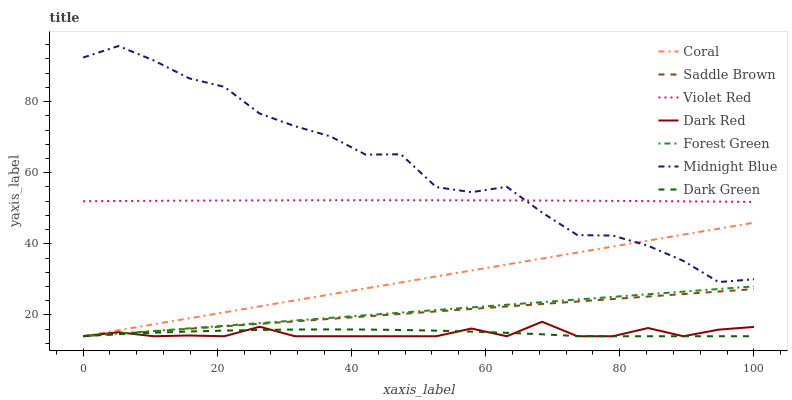Does Dark Red have the minimum area under the curve?
Answer yes or no. Yes. Does Midnight Blue have the maximum area under the curve?
Answer yes or no. Yes. Does Midnight Blue have the minimum area under the curve?
Answer yes or no. No. Does Dark Red have the maximum area under the curve?
Answer yes or no. No. Is Saddle Brown the smoothest?
Answer yes or no. Yes. Is Midnight Blue the roughest?
Answer yes or no. Yes. Is Dark Red the smoothest?
Answer yes or no. No. Is Dark Red the roughest?
Answer yes or no. No. Does Dark Red have the lowest value?
Answer yes or no. Yes. Does Midnight Blue have the lowest value?
Answer yes or no. No. Does Midnight Blue have the highest value?
Answer yes or no. Yes. Does Dark Red have the highest value?
Answer yes or no. No. Is Dark Green less than Violet Red?
Answer yes or no. Yes. Is Violet Red greater than Saddle Brown?
Answer yes or no. Yes. Does Saddle Brown intersect Dark Red?
Answer yes or no. Yes. Is Saddle Brown less than Dark Red?
Answer yes or no. No. Is Saddle Brown greater than Dark Red?
Answer yes or no. No. Does Dark Green intersect Violet Red?
Answer yes or no. No. 